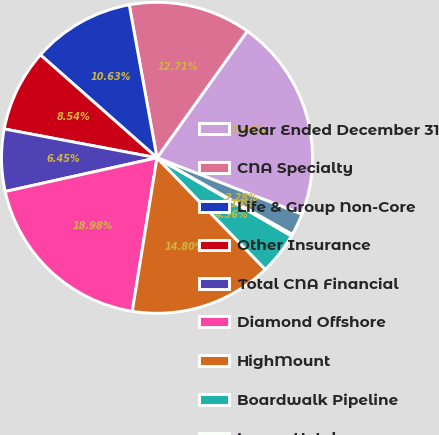<chart> <loc_0><loc_0><loc_500><loc_500><pie_chart><fcel>Year Ended December 31<fcel>CNA Specialty<fcel>Life & Group Non-Core<fcel>Other Insurance<fcel>Total CNA Financial<fcel>Diamond Offshore<fcel>HighMount<fcel>Boardwalk Pipeline<fcel>Loews Hotels<fcel>Corporate and other<nl><fcel>21.06%<fcel>12.71%<fcel>10.63%<fcel>8.54%<fcel>6.45%<fcel>18.98%<fcel>14.8%<fcel>4.36%<fcel>0.19%<fcel>2.28%<nl></chart> 